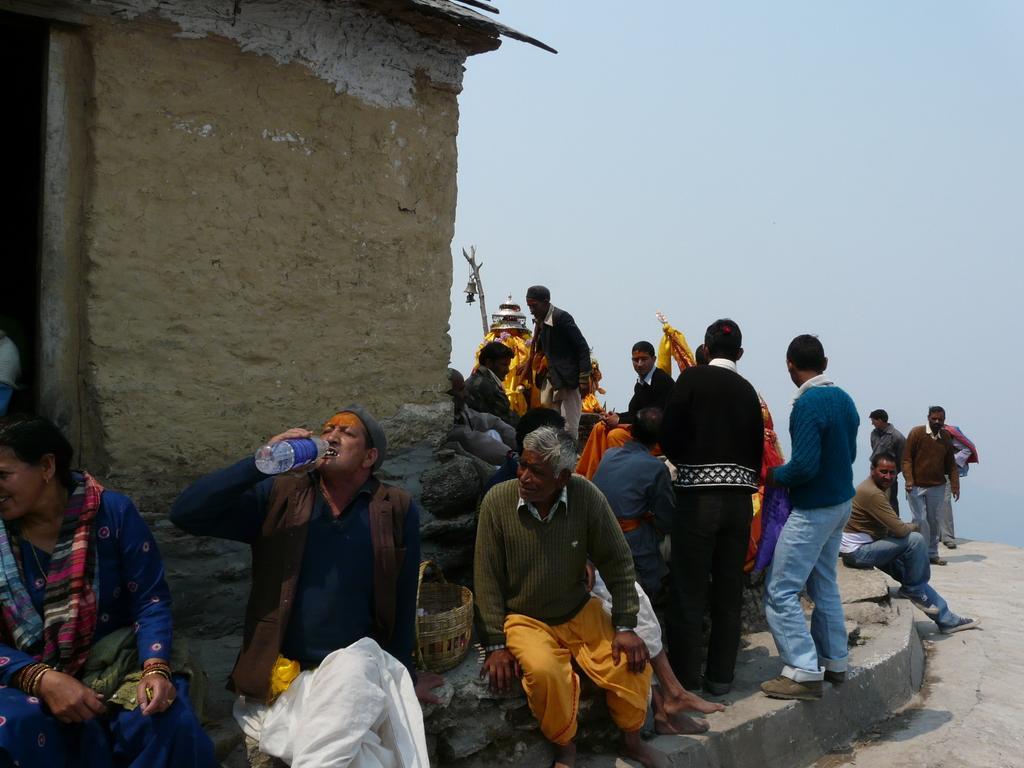Can you describe this image briefly? In this image, we can see some people sitting, there are some people standing, we can see a wall, at the top there is a sky. 